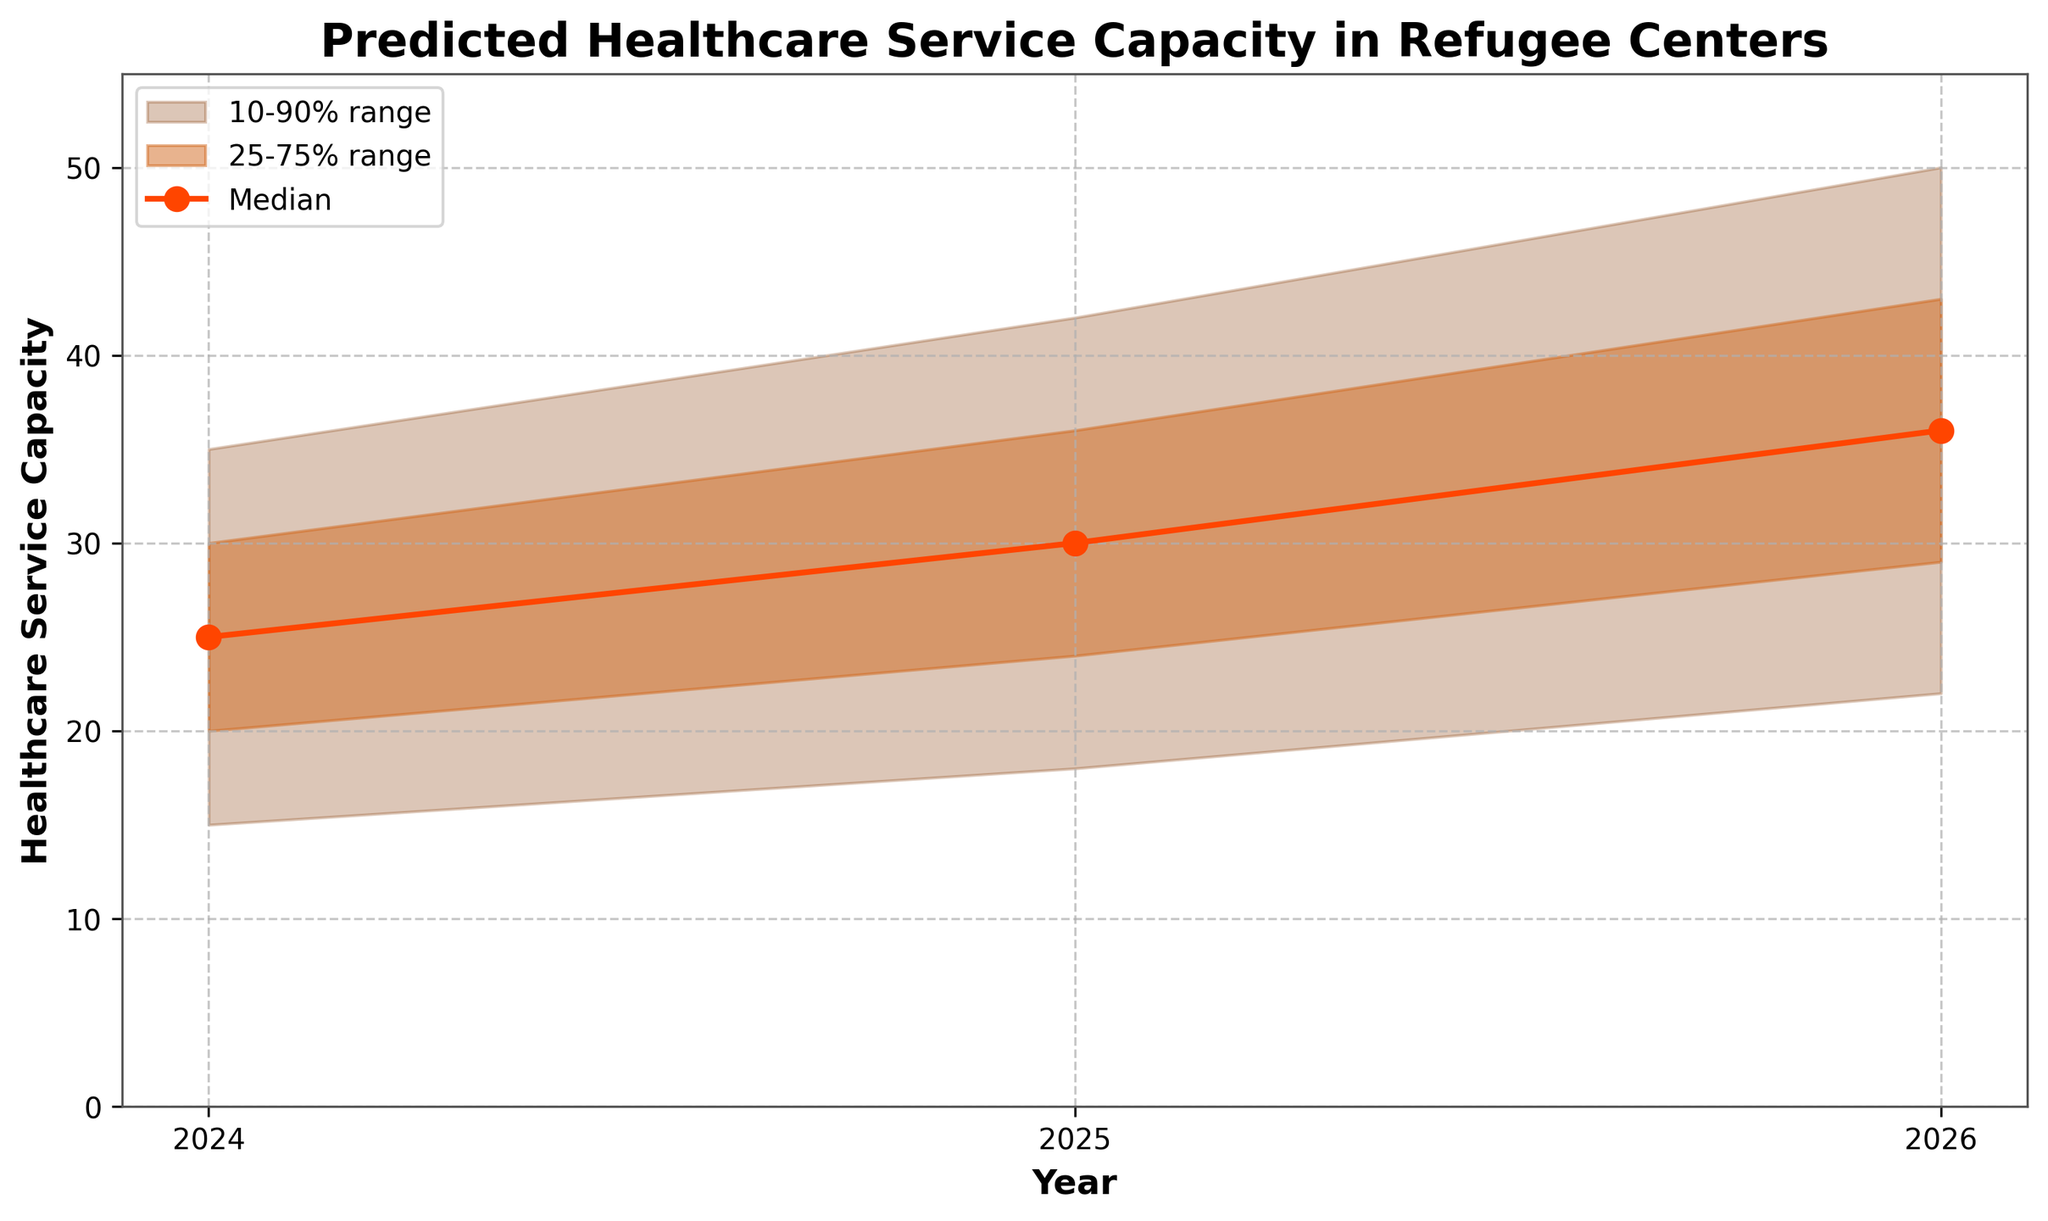What's the title of the chart? The title of the chart can be found at the top and reads: "Predicted Healthcare Service Capacity in Refugee Centers".
Answer: Predicted Healthcare Service Capacity in Refugee Centers What years are covered in the chart? The x-axis of the chart displays the years included in the prediction. These are 2024, 2025, and 2026.
Answer: 2024, 2025, 2026 What color is used for the median line? The median line is depicted in a different color, which is a noticeable bright color. Looking at the plot, the median line is orange.
Answer: Orange What is the predicted median healthcare service capacity for 2024? Observing the plot, you can see that the median value for 2024 is highlighted on the line graph. It is located at the point corresponding to 2024, which gives a value of 25.
Answer: 25 By how much is the median expected to increase from 2024 to 2025? The median value for 2024 is 25, while for 2025, it is 30. The increase is calculated as 30 - 25.
Answer: 5 What is the range between the upper and lower bounds (10% and 90%) for 2026? The upper bound (90%) for 2026 is 50, and the lower bound (10%) for 2026 is 22. The range is 50 - 22.
Answer: 28 Which year has the largest uncertainty in healthcare capacity predictions (considering 10-90% range)? Uncertainty can be measured by the spread between the 10th percentile (Lower10) and the 90th percentile (Upper10). For 2024, the range is 35 - 15 = 20. For 2025, it is 42 - 18 = 24. For 2026, it is 50 - 22 = 28. The largest range is for 2026.
Answer: 2026 How does the capacity prediction vary within the 25-75% range in 2025? The 25th percentile (Lower25) for 2025 is 24, and the 75th percentile (Upper25) for 2025 is 36. The variation within the 25-75% range for 2025 is 36 - 24.
Answer: 12 What is the predicted 90th percentile capacity for 2025? The upper bound of the 10-90% range for 2025 can be observed at the topmost point of the shaded region for that year. This value is 42.
Answer: 42 Which year shows the highest median healthcare service capacity prediction? The median values for 2024, 2025, and 2026 are 25, 30, and 36 respectively. The highest median capacity is for 2026.
Answer: 2026 